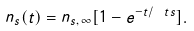<formula> <loc_0><loc_0><loc_500><loc_500>n _ { s } ( t ) = n _ { s , \, \infty } [ 1 - e ^ { - t / \ t s } ] .</formula> 